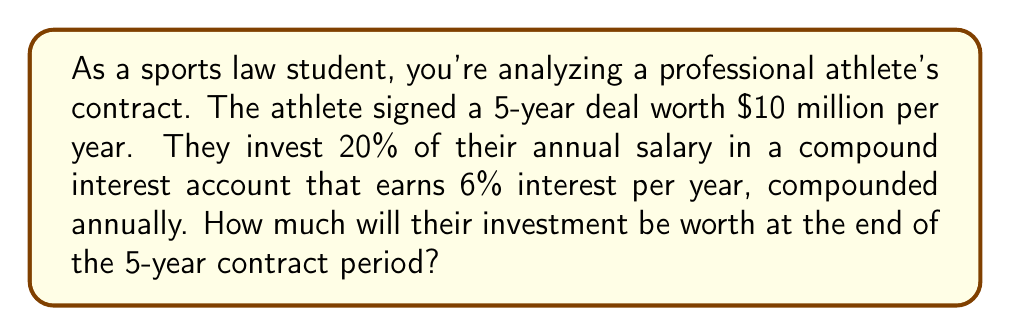What is the answer to this math problem? Let's break this down step-by-step:

1. Calculate the annual investment amount:
   $10,000,000 \times 20\% = $2,000,000$

2. We'll use the compound interest formula:
   $A = P(1 + r)^n$
   Where:
   $A$ = final amount
   $P$ = principal (initial investment)
   $r$ = annual interest rate (as a decimal)
   $n$ = number of years

3. Plug in the values:
   $P = $2,000,000$
   $r = 6\% = 0.06$
   $n = 5$ years

4. Calculate:
   $A = 2,000,000(1 + 0.06)^5$
   $A = 2,000,000(1.06)^5$
   $A = 2,000,000(1.3382256)$
   $A = 2,676,451.20$

5. However, this is just for the first year's investment. We need to repeat this for each year's investment:

   Year 1: $2,000,000(1.06)^5 = 2,676,451.20$
   Year 2: $2,000,000(1.06)^4 = 2,524,955.85$
   Year 3: $2,000,000(1.06)^3 = 2,382,033.82$
   Year 4: $2,000,000(1.06)^2 = 2,247,200.00$
   Year 5: $2,000,000(1.06)^1 = 2,120,000.00$

6. Sum up all these amounts:
   $2,676,451.20 + 2,524,955.85 + 2,382,033.82 + 2,247,200.00 + 2,120,000.00 = 11,950,640.87$
Answer: $11,950,640.87 